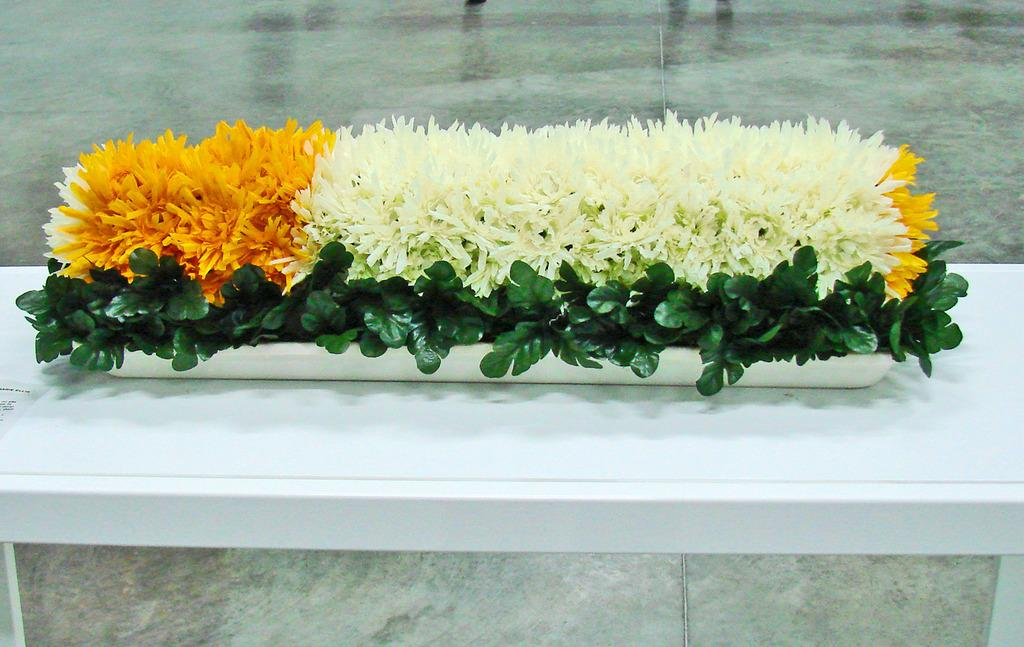What is in the foreground of the image? There are flowers in a tray in the foreground of the image. Where are the flowers located? The flowers are on a table. Can you determine the time of day the image was taken? The image is likely taken during the day, as there is sufficient light. Where was the image taken? The image was taken inside a building. What type of yam can be seen growing in the background of the image? There is no yam present in the image; it features flowers in a tray on a table. Is the judge present in the image? There is no judge present in the image. 